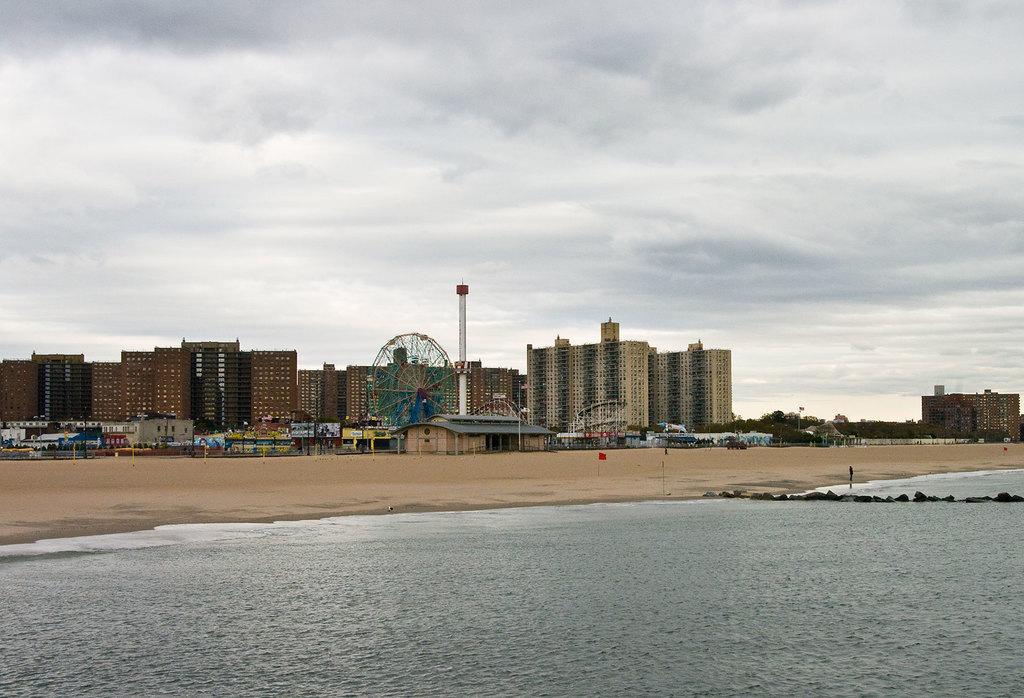Could you give a brief overview of what you see in this image? At the center of the image there are some buildings, stalls and poles. At the bottom of the image there is a river. In the background there is a sky. 